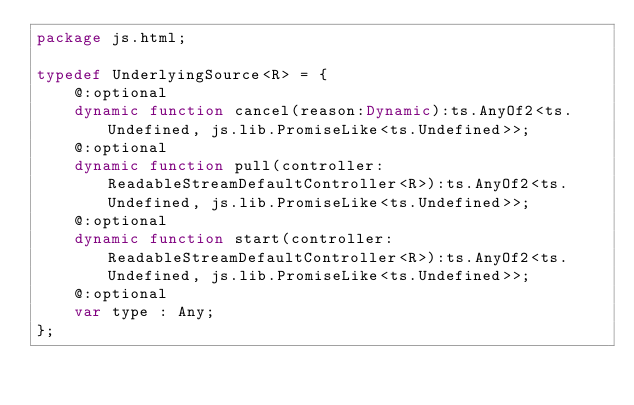<code> <loc_0><loc_0><loc_500><loc_500><_Haxe_>package js.html;

typedef UnderlyingSource<R> = {
	@:optional
	dynamic function cancel(reason:Dynamic):ts.AnyOf2<ts.Undefined, js.lib.PromiseLike<ts.Undefined>>;
	@:optional
	dynamic function pull(controller:ReadableStreamDefaultController<R>):ts.AnyOf2<ts.Undefined, js.lib.PromiseLike<ts.Undefined>>;
	@:optional
	dynamic function start(controller:ReadableStreamDefaultController<R>):ts.AnyOf2<ts.Undefined, js.lib.PromiseLike<ts.Undefined>>;
	@:optional
	var type : Any;
};</code> 